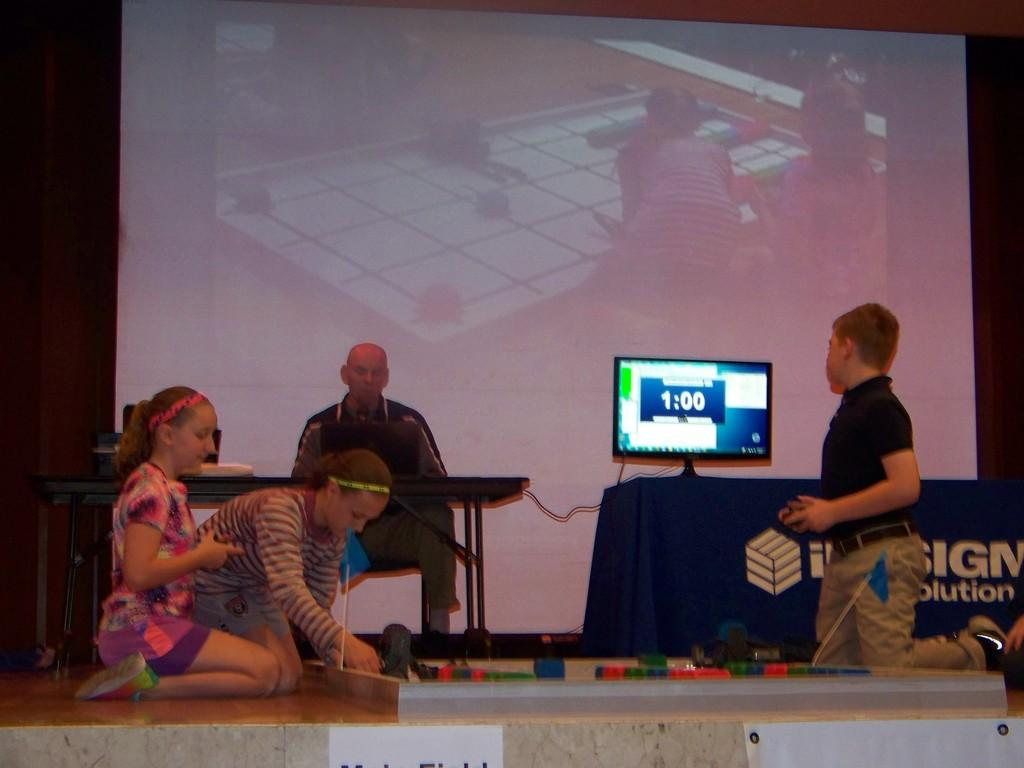<image>
Give a short and clear explanation of the subsequent image. a screen with the time of 1:00 on it 